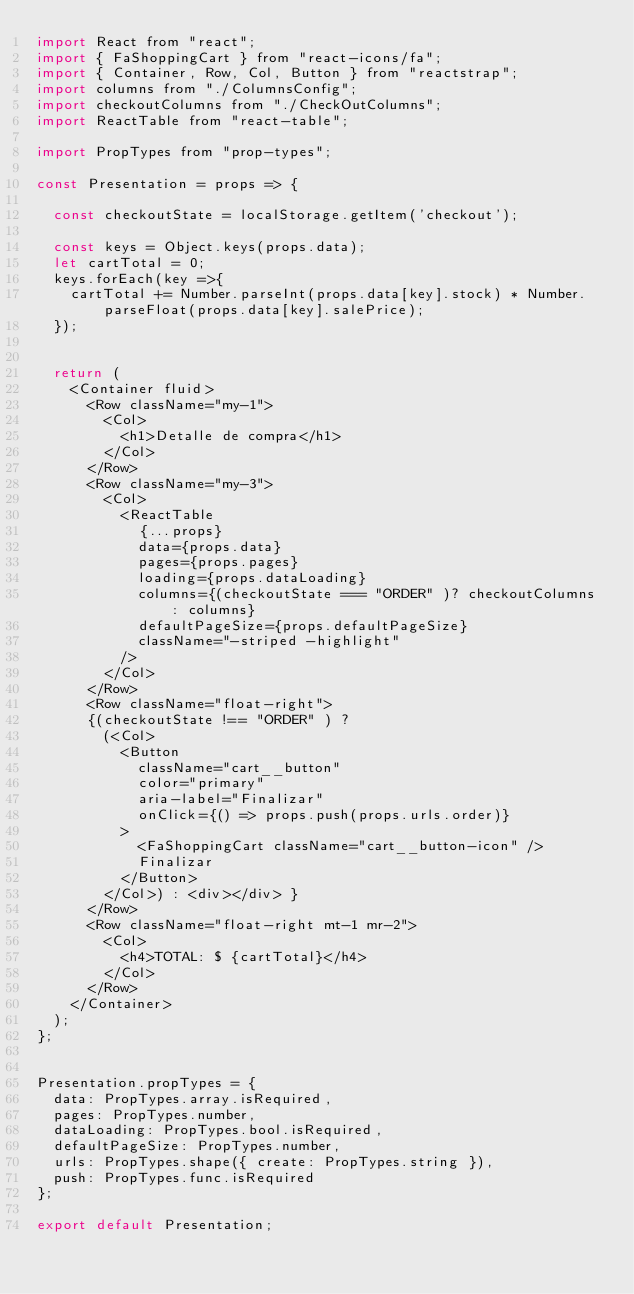Convert code to text. <code><loc_0><loc_0><loc_500><loc_500><_JavaScript_>import React from "react";
import { FaShoppingCart } from "react-icons/fa";
import { Container, Row, Col, Button } from "reactstrap";
import columns from "./ColumnsConfig";
import checkoutColumns from "./CheckOutColumns";
import ReactTable from "react-table";

import PropTypes from "prop-types";

const Presentation = props => {

  const checkoutState = localStorage.getItem('checkout');
  
  const keys = Object.keys(props.data);
  let cartTotal = 0;
  keys.forEach(key =>{
    cartTotal += Number.parseInt(props.data[key].stock) * Number.parseFloat(props.data[key].salePrice); 
  });
  
  
  return (
    <Container fluid>
      <Row className="my-1">
        <Col>
          <h1>Detalle de compra</h1>
        </Col>
      </Row>      
      <Row className="my-3">
        <Col>
          <ReactTable
            {...props}
            data={props.data}
            pages={props.pages} 
            loading={props.dataLoading}
            columns={(checkoutState === "ORDER" )? checkoutColumns : columns}
            defaultPageSize={props.defaultPageSize}
            className="-striped -highlight"
          />
        </Col>
      </Row>
      <Row className="float-right">
      {(checkoutState !== "ORDER" ) ? 
        (<Col>
          <Button
            className="cart__button"
            color="primary"
            aria-label="Finalizar"
            onClick={() => props.push(props.urls.order)}
          >
            <FaShoppingCart className="cart__button-icon" />
            Finalizar
          </Button>
        </Col>) : <div></div> }
      </Row>
      <Row className="float-right mt-1 mr-2">
        <Col>
          <h4>TOTAL: $ {cartTotal}</h4>
        </Col>        
      </Row>
    </Container>
  );
};


Presentation.propTypes = {
  data: PropTypes.array.isRequired,
  pages: PropTypes.number,
  dataLoading: PropTypes.bool.isRequired,
  defaultPageSize: PropTypes.number,
  urls: PropTypes.shape({ create: PropTypes.string }),
  push: PropTypes.func.isRequired
};

export default Presentation;
</code> 